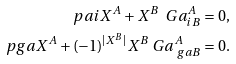<formula> <loc_0><loc_0><loc_500><loc_500>\ p a i X ^ { A } + X ^ { B } \ G a ^ { A } _ { i B } & = 0 , \\ \ p g a X ^ { A } + ( - 1 ) ^ { | X ^ { B } | } X ^ { B } \ G a ^ { A } _ { \ g a B } & = 0 .</formula> 